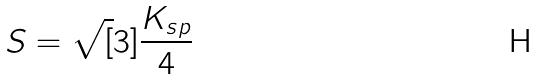<formula> <loc_0><loc_0><loc_500><loc_500>S = \sqrt { [ } 3 ] { \frac { K _ { s p } } { 4 } }</formula> 